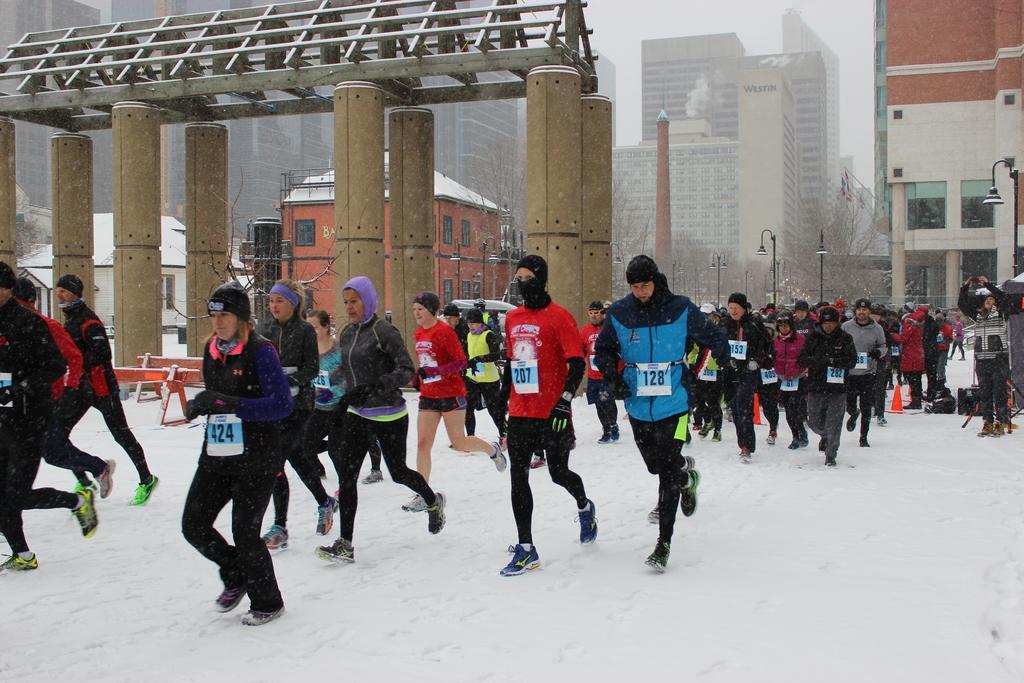Describe this image in one or two sentences. In the center of the image we can see a group of people are running. In the background of the image we can see buildings, shed, electric light poles, tree, tower are there. At the top of the image sky is present. At the bottom of the image snow is there. 